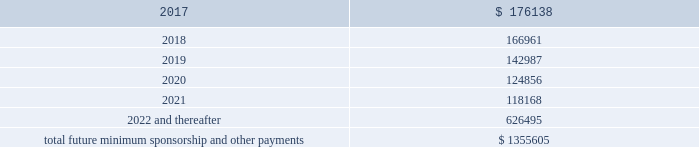2016 , as well as significant sponsorship and other marketing agreements entered into during the period after december 31 , 2016 through the date of this report : ( in thousands ) .
Total future minimum sponsorship and other payments $ 1355605 the amounts listed above are the minimum compensation obligations and guaranteed royalty fees required to be paid under the company 2019s sponsorship and other marketing agreements .
The amounts listed above do not include additional performance incentives and product supply obligations provided under certain agreements .
It is not possible to determine how much the company will spend on product supply obligations on an annual basis as contracts generally do not stipulate specific cash amounts to be spent on products .
The amount of product provided to the sponsorships depends on many factors including general playing conditions , the number of sporting events in which they participate and the company 2019s decisions regarding product and marketing initiatives .
In addition , the costs to design , develop , source and purchase the products furnished to the endorsers are incurred over a period of time and are not necessarily tracked separately from similar costs incurred for products sold to customers .
In connection with various contracts and agreements , the company has agreed to indemnify counterparties against certain third party claims relating to the infringement of intellectual property rights and other items .
Generally , such indemnification obligations do not apply in situations in which the counterparties are grossly negligent , engage in willful misconduct , or act in bad faith .
Based on the company 2019s historical experience and the estimated probability of future loss , the company has determined that the fair value of such indemnifications is not material to its consolidated financial position or results of operations .
From time to time , the company is involved in litigation and other proceedings , including matters related to commercial and intellectual property disputes , as well as trade , regulatory and other claims related to its business .
Other than as described below , the company believes that all current proceedings are routine in nature and incidental to the conduct of its business , and that the ultimate resolution of any such proceedings will not have a material adverse effect on its consolidated financial position , results of operations or cash flows .
On february 10 , 2017 , a shareholder filed a securities case in the united states district court for the district of maryland ( the 201ccourt 201d ) against the company , the company 2019s chief executive officer and the company 2019s former chief financial officer ( brian breece v .
Under armour , inc. ) .
On february 16 , 2017 , a second shareholder filed a securities case in the court against the same defendants ( jodie hopkins v .
Under armour , inc. ) .
The plaintiff in each case purports to represent a class of shareholders for the period between april 21 , 2016 and january 30 , 2017 , inclusive .
The complaints allege violations of section 10 ( b ) ( and rule 10b-5 ) of the securities exchange act of 1934 , as amended ( the 201cexchange act 201d ) and section 20 ( a ) control person liability under the exchange act against the officers named in the complaints .
In general , the allegations in each case concern disclosures and statements made by .
What portion of the total future minimum sponsorship and other payments will be due in the next 12 months? 
Computations: (176138 / 1355605)
Answer: 0.12993. 